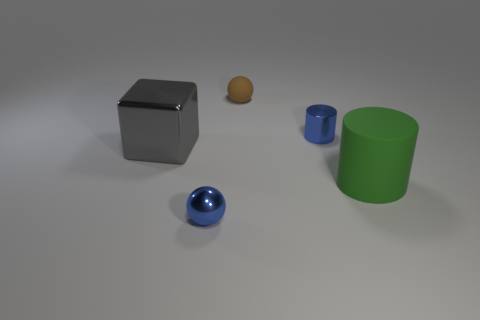Can you describe the overall setting or atmosphere the image conveys? The image portrays a simplistic yet thoughtfully arranged scene. There is a sense of quiet and calmness, emphasized by the soft lighting and the neutral background. The limited color palette, consisting primarily of the objects' innate colors against what appears to be a grey floor, suggests an almost clinical or experimental setting. It feels like each object was placed with intention, possibly for a study in material properties or a visual study in composition and form. 